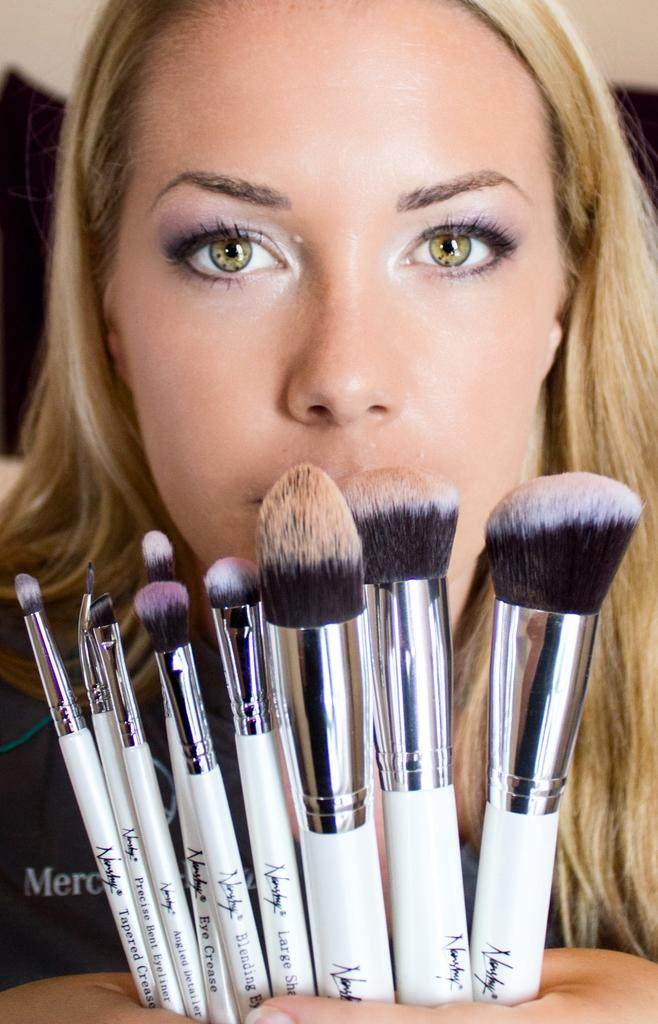Who is the main subject in the image? There is a woman in the image. What is the woman holding in the image? The woman is holding brushes. Can you describe the background of the image? The background of the image is blurred. What type of treatment is the woman receiving in the image? There is no indication in the image that the woman is receiving any treatment. 